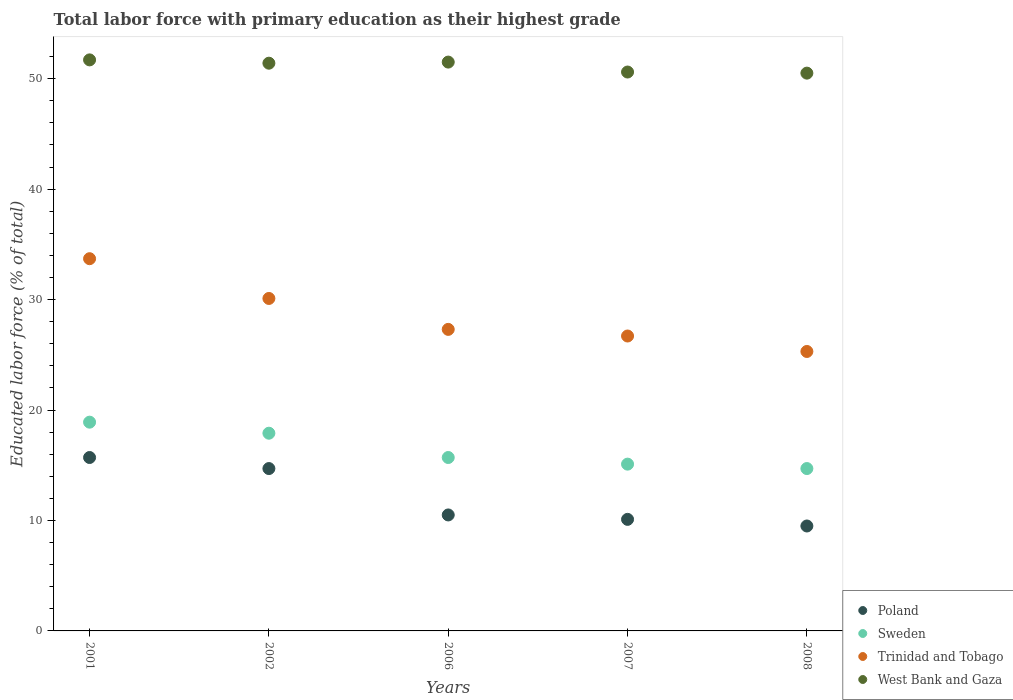How many different coloured dotlines are there?
Your answer should be very brief. 4. Is the number of dotlines equal to the number of legend labels?
Ensure brevity in your answer.  Yes. What is the percentage of total labor force with primary education in Poland in 2008?
Offer a very short reply. 9.5. Across all years, what is the maximum percentage of total labor force with primary education in Poland?
Your response must be concise. 15.7. Across all years, what is the minimum percentage of total labor force with primary education in Poland?
Make the answer very short. 9.5. In which year was the percentage of total labor force with primary education in West Bank and Gaza maximum?
Provide a short and direct response. 2001. What is the total percentage of total labor force with primary education in Sweden in the graph?
Give a very brief answer. 82.3. What is the difference between the percentage of total labor force with primary education in Trinidad and Tobago in 2001 and that in 2002?
Your response must be concise. 3.6. What is the difference between the percentage of total labor force with primary education in Trinidad and Tobago in 2006 and the percentage of total labor force with primary education in Sweden in 2002?
Your response must be concise. 9.4. What is the average percentage of total labor force with primary education in Sweden per year?
Give a very brief answer. 16.46. In the year 2002, what is the difference between the percentage of total labor force with primary education in Sweden and percentage of total labor force with primary education in West Bank and Gaza?
Make the answer very short. -33.5. In how many years, is the percentage of total labor force with primary education in Poland greater than 16 %?
Provide a succinct answer. 0. What is the ratio of the percentage of total labor force with primary education in Trinidad and Tobago in 2001 to that in 2008?
Make the answer very short. 1.33. Is the percentage of total labor force with primary education in Sweden in 2001 less than that in 2007?
Provide a short and direct response. No. Is the difference between the percentage of total labor force with primary education in Sweden in 2002 and 2006 greater than the difference between the percentage of total labor force with primary education in West Bank and Gaza in 2002 and 2006?
Offer a very short reply. Yes. What is the difference between the highest and the lowest percentage of total labor force with primary education in West Bank and Gaza?
Make the answer very short. 1.2. In how many years, is the percentage of total labor force with primary education in Poland greater than the average percentage of total labor force with primary education in Poland taken over all years?
Your answer should be compact. 2. Is it the case that in every year, the sum of the percentage of total labor force with primary education in Trinidad and Tobago and percentage of total labor force with primary education in West Bank and Gaza  is greater than the percentage of total labor force with primary education in Sweden?
Your answer should be compact. Yes. Is the percentage of total labor force with primary education in Sweden strictly greater than the percentage of total labor force with primary education in West Bank and Gaza over the years?
Keep it short and to the point. No. How many dotlines are there?
Your response must be concise. 4. What is the difference between two consecutive major ticks on the Y-axis?
Make the answer very short. 10. Does the graph contain grids?
Your answer should be very brief. No. Where does the legend appear in the graph?
Provide a succinct answer. Bottom right. How many legend labels are there?
Make the answer very short. 4. What is the title of the graph?
Your answer should be compact. Total labor force with primary education as their highest grade. Does "Kazakhstan" appear as one of the legend labels in the graph?
Provide a succinct answer. No. What is the label or title of the X-axis?
Ensure brevity in your answer.  Years. What is the label or title of the Y-axis?
Offer a very short reply. Educated labor force (% of total). What is the Educated labor force (% of total) of Poland in 2001?
Provide a short and direct response. 15.7. What is the Educated labor force (% of total) in Sweden in 2001?
Offer a terse response. 18.9. What is the Educated labor force (% of total) in Trinidad and Tobago in 2001?
Your answer should be compact. 33.7. What is the Educated labor force (% of total) of West Bank and Gaza in 2001?
Your response must be concise. 51.7. What is the Educated labor force (% of total) in Poland in 2002?
Provide a short and direct response. 14.7. What is the Educated labor force (% of total) of Sweden in 2002?
Provide a succinct answer. 17.9. What is the Educated labor force (% of total) of Trinidad and Tobago in 2002?
Provide a succinct answer. 30.1. What is the Educated labor force (% of total) of West Bank and Gaza in 2002?
Provide a succinct answer. 51.4. What is the Educated labor force (% of total) of Poland in 2006?
Your answer should be compact. 10.5. What is the Educated labor force (% of total) of Sweden in 2006?
Your answer should be compact. 15.7. What is the Educated labor force (% of total) of Trinidad and Tobago in 2006?
Provide a short and direct response. 27.3. What is the Educated labor force (% of total) of West Bank and Gaza in 2006?
Offer a terse response. 51.5. What is the Educated labor force (% of total) of Poland in 2007?
Provide a short and direct response. 10.1. What is the Educated labor force (% of total) in Sweden in 2007?
Offer a very short reply. 15.1. What is the Educated labor force (% of total) in Trinidad and Tobago in 2007?
Your response must be concise. 26.7. What is the Educated labor force (% of total) of West Bank and Gaza in 2007?
Your answer should be very brief. 50.6. What is the Educated labor force (% of total) of Sweden in 2008?
Ensure brevity in your answer.  14.7. What is the Educated labor force (% of total) of Trinidad and Tobago in 2008?
Make the answer very short. 25.3. What is the Educated labor force (% of total) in West Bank and Gaza in 2008?
Make the answer very short. 50.5. Across all years, what is the maximum Educated labor force (% of total) in Poland?
Provide a short and direct response. 15.7. Across all years, what is the maximum Educated labor force (% of total) of Sweden?
Provide a succinct answer. 18.9. Across all years, what is the maximum Educated labor force (% of total) of Trinidad and Tobago?
Offer a terse response. 33.7. Across all years, what is the maximum Educated labor force (% of total) in West Bank and Gaza?
Offer a very short reply. 51.7. Across all years, what is the minimum Educated labor force (% of total) of Poland?
Keep it short and to the point. 9.5. Across all years, what is the minimum Educated labor force (% of total) of Sweden?
Your answer should be very brief. 14.7. Across all years, what is the minimum Educated labor force (% of total) of Trinidad and Tobago?
Keep it short and to the point. 25.3. Across all years, what is the minimum Educated labor force (% of total) of West Bank and Gaza?
Your answer should be very brief. 50.5. What is the total Educated labor force (% of total) of Poland in the graph?
Offer a terse response. 60.5. What is the total Educated labor force (% of total) of Sweden in the graph?
Your answer should be very brief. 82.3. What is the total Educated labor force (% of total) of Trinidad and Tobago in the graph?
Provide a succinct answer. 143.1. What is the total Educated labor force (% of total) of West Bank and Gaza in the graph?
Ensure brevity in your answer.  255.7. What is the difference between the Educated labor force (% of total) of Sweden in 2001 and that in 2002?
Provide a succinct answer. 1. What is the difference between the Educated labor force (% of total) of Sweden in 2001 and that in 2006?
Offer a terse response. 3.2. What is the difference between the Educated labor force (% of total) of Trinidad and Tobago in 2001 and that in 2006?
Your answer should be compact. 6.4. What is the difference between the Educated labor force (% of total) of Poland in 2001 and that in 2007?
Give a very brief answer. 5.6. What is the difference between the Educated labor force (% of total) in West Bank and Gaza in 2001 and that in 2007?
Your response must be concise. 1.1. What is the difference between the Educated labor force (% of total) of Poland in 2001 and that in 2008?
Give a very brief answer. 6.2. What is the difference between the Educated labor force (% of total) in Trinidad and Tobago in 2001 and that in 2008?
Provide a succinct answer. 8.4. What is the difference between the Educated labor force (% of total) of West Bank and Gaza in 2002 and that in 2006?
Provide a short and direct response. -0.1. What is the difference between the Educated labor force (% of total) in Poland in 2002 and that in 2007?
Offer a very short reply. 4.6. What is the difference between the Educated labor force (% of total) of Trinidad and Tobago in 2002 and that in 2007?
Provide a short and direct response. 3.4. What is the difference between the Educated labor force (% of total) of Poland in 2006 and that in 2007?
Your response must be concise. 0.4. What is the difference between the Educated labor force (% of total) of Trinidad and Tobago in 2006 and that in 2007?
Make the answer very short. 0.6. What is the difference between the Educated labor force (% of total) of Sweden in 2006 and that in 2008?
Offer a terse response. 1. What is the difference between the Educated labor force (% of total) in Poland in 2007 and that in 2008?
Make the answer very short. 0.6. What is the difference between the Educated labor force (% of total) in West Bank and Gaza in 2007 and that in 2008?
Make the answer very short. 0.1. What is the difference between the Educated labor force (% of total) of Poland in 2001 and the Educated labor force (% of total) of Sweden in 2002?
Your answer should be compact. -2.2. What is the difference between the Educated labor force (% of total) of Poland in 2001 and the Educated labor force (% of total) of Trinidad and Tobago in 2002?
Provide a short and direct response. -14.4. What is the difference between the Educated labor force (% of total) in Poland in 2001 and the Educated labor force (% of total) in West Bank and Gaza in 2002?
Your answer should be very brief. -35.7. What is the difference between the Educated labor force (% of total) in Sweden in 2001 and the Educated labor force (% of total) in West Bank and Gaza in 2002?
Keep it short and to the point. -32.5. What is the difference between the Educated labor force (% of total) of Trinidad and Tobago in 2001 and the Educated labor force (% of total) of West Bank and Gaza in 2002?
Ensure brevity in your answer.  -17.7. What is the difference between the Educated labor force (% of total) of Poland in 2001 and the Educated labor force (% of total) of West Bank and Gaza in 2006?
Keep it short and to the point. -35.8. What is the difference between the Educated labor force (% of total) of Sweden in 2001 and the Educated labor force (% of total) of Trinidad and Tobago in 2006?
Your answer should be compact. -8.4. What is the difference between the Educated labor force (% of total) in Sweden in 2001 and the Educated labor force (% of total) in West Bank and Gaza in 2006?
Your response must be concise. -32.6. What is the difference between the Educated labor force (% of total) of Trinidad and Tobago in 2001 and the Educated labor force (% of total) of West Bank and Gaza in 2006?
Keep it short and to the point. -17.8. What is the difference between the Educated labor force (% of total) of Poland in 2001 and the Educated labor force (% of total) of Sweden in 2007?
Offer a very short reply. 0.6. What is the difference between the Educated labor force (% of total) in Poland in 2001 and the Educated labor force (% of total) in Trinidad and Tobago in 2007?
Ensure brevity in your answer.  -11. What is the difference between the Educated labor force (% of total) in Poland in 2001 and the Educated labor force (% of total) in West Bank and Gaza in 2007?
Make the answer very short. -34.9. What is the difference between the Educated labor force (% of total) in Sweden in 2001 and the Educated labor force (% of total) in Trinidad and Tobago in 2007?
Give a very brief answer. -7.8. What is the difference between the Educated labor force (% of total) of Sweden in 2001 and the Educated labor force (% of total) of West Bank and Gaza in 2007?
Offer a very short reply. -31.7. What is the difference between the Educated labor force (% of total) of Trinidad and Tobago in 2001 and the Educated labor force (% of total) of West Bank and Gaza in 2007?
Your answer should be very brief. -16.9. What is the difference between the Educated labor force (% of total) of Poland in 2001 and the Educated labor force (% of total) of Sweden in 2008?
Offer a very short reply. 1. What is the difference between the Educated labor force (% of total) in Poland in 2001 and the Educated labor force (% of total) in West Bank and Gaza in 2008?
Your response must be concise. -34.8. What is the difference between the Educated labor force (% of total) of Sweden in 2001 and the Educated labor force (% of total) of Trinidad and Tobago in 2008?
Provide a succinct answer. -6.4. What is the difference between the Educated labor force (% of total) of Sweden in 2001 and the Educated labor force (% of total) of West Bank and Gaza in 2008?
Keep it short and to the point. -31.6. What is the difference between the Educated labor force (% of total) in Trinidad and Tobago in 2001 and the Educated labor force (% of total) in West Bank and Gaza in 2008?
Ensure brevity in your answer.  -16.8. What is the difference between the Educated labor force (% of total) of Poland in 2002 and the Educated labor force (% of total) of West Bank and Gaza in 2006?
Provide a succinct answer. -36.8. What is the difference between the Educated labor force (% of total) of Sweden in 2002 and the Educated labor force (% of total) of West Bank and Gaza in 2006?
Give a very brief answer. -33.6. What is the difference between the Educated labor force (% of total) of Trinidad and Tobago in 2002 and the Educated labor force (% of total) of West Bank and Gaza in 2006?
Make the answer very short. -21.4. What is the difference between the Educated labor force (% of total) in Poland in 2002 and the Educated labor force (% of total) in Sweden in 2007?
Keep it short and to the point. -0.4. What is the difference between the Educated labor force (% of total) of Poland in 2002 and the Educated labor force (% of total) of Trinidad and Tobago in 2007?
Ensure brevity in your answer.  -12. What is the difference between the Educated labor force (% of total) of Poland in 2002 and the Educated labor force (% of total) of West Bank and Gaza in 2007?
Your response must be concise. -35.9. What is the difference between the Educated labor force (% of total) in Sweden in 2002 and the Educated labor force (% of total) in West Bank and Gaza in 2007?
Give a very brief answer. -32.7. What is the difference between the Educated labor force (% of total) of Trinidad and Tobago in 2002 and the Educated labor force (% of total) of West Bank and Gaza in 2007?
Provide a short and direct response. -20.5. What is the difference between the Educated labor force (% of total) in Poland in 2002 and the Educated labor force (% of total) in Sweden in 2008?
Your response must be concise. 0. What is the difference between the Educated labor force (% of total) of Poland in 2002 and the Educated labor force (% of total) of Trinidad and Tobago in 2008?
Your answer should be very brief. -10.6. What is the difference between the Educated labor force (% of total) in Poland in 2002 and the Educated labor force (% of total) in West Bank and Gaza in 2008?
Offer a very short reply. -35.8. What is the difference between the Educated labor force (% of total) in Sweden in 2002 and the Educated labor force (% of total) in West Bank and Gaza in 2008?
Give a very brief answer. -32.6. What is the difference between the Educated labor force (% of total) of Trinidad and Tobago in 2002 and the Educated labor force (% of total) of West Bank and Gaza in 2008?
Offer a very short reply. -20.4. What is the difference between the Educated labor force (% of total) of Poland in 2006 and the Educated labor force (% of total) of Sweden in 2007?
Keep it short and to the point. -4.6. What is the difference between the Educated labor force (% of total) of Poland in 2006 and the Educated labor force (% of total) of Trinidad and Tobago in 2007?
Your response must be concise. -16.2. What is the difference between the Educated labor force (% of total) in Poland in 2006 and the Educated labor force (% of total) in West Bank and Gaza in 2007?
Offer a terse response. -40.1. What is the difference between the Educated labor force (% of total) in Sweden in 2006 and the Educated labor force (% of total) in Trinidad and Tobago in 2007?
Offer a very short reply. -11. What is the difference between the Educated labor force (% of total) of Sweden in 2006 and the Educated labor force (% of total) of West Bank and Gaza in 2007?
Keep it short and to the point. -34.9. What is the difference between the Educated labor force (% of total) of Trinidad and Tobago in 2006 and the Educated labor force (% of total) of West Bank and Gaza in 2007?
Ensure brevity in your answer.  -23.3. What is the difference between the Educated labor force (% of total) of Poland in 2006 and the Educated labor force (% of total) of Trinidad and Tobago in 2008?
Ensure brevity in your answer.  -14.8. What is the difference between the Educated labor force (% of total) of Poland in 2006 and the Educated labor force (% of total) of West Bank and Gaza in 2008?
Provide a succinct answer. -40. What is the difference between the Educated labor force (% of total) in Sweden in 2006 and the Educated labor force (% of total) in West Bank and Gaza in 2008?
Provide a succinct answer. -34.8. What is the difference between the Educated labor force (% of total) in Trinidad and Tobago in 2006 and the Educated labor force (% of total) in West Bank and Gaza in 2008?
Make the answer very short. -23.2. What is the difference between the Educated labor force (% of total) of Poland in 2007 and the Educated labor force (% of total) of Trinidad and Tobago in 2008?
Provide a short and direct response. -15.2. What is the difference between the Educated labor force (% of total) of Poland in 2007 and the Educated labor force (% of total) of West Bank and Gaza in 2008?
Ensure brevity in your answer.  -40.4. What is the difference between the Educated labor force (% of total) of Sweden in 2007 and the Educated labor force (% of total) of Trinidad and Tobago in 2008?
Your answer should be very brief. -10.2. What is the difference between the Educated labor force (% of total) in Sweden in 2007 and the Educated labor force (% of total) in West Bank and Gaza in 2008?
Your answer should be very brief. -35.4. What is the difference between the Educated labor force (% of total) of Trinidad and Tobago in 2007 and the Educated labor force (% of total) of West Bank and Gaza in 2008?
Ensure brevity in your answer.  -23.8. What is the average Educated labor force (% of total) in Poland per year?
Provide a short and direct response. 12.1. What is the average Educated labor force (% of total) in Sweden per year?
Make the answer very short. 16.46. What is the average Educated labor force (% of total) in Trinidad and Tobago per year?
Make the answer very short. 28.62. What is the average Educated labor force (% of total) of West Bank and Gaza per year?
Your response must be concise. 51.14. In the year 2001, what is the difference between the Educated labor force (% of total) in Poland and Educated labor force (% of total) in West Bank and Gaza?
Offer a terse response. -36. In the year 2001, what is the difference between the Educated labor force (% of total) of Sweden and Educated labor force (% of total) of Trinidad and Tobago?
Provide a short and direct response. -14.8. In the year 2001, what is the difference between the Educated labor force (% of total) of Sweden and Educated labor force (% of total) of West Bank and Gaza?
Your response must be concise. -32.8. In the year 2001, what is the difference between the Educated labor force (% of total) in Trinidad and Tobago and Educated labor force (% of total) in West Bank and Gaza?
Offer a very short reply. -18. In the year 2002, what is the difference between the Educated labor force (% of total) in Poland and Educated labor force (% of total) in Sweden?
Make the answer very short. -3.2. In the year 2002, what is the difference between the Educated labor force (% of total) in Poland and Educated labor force (% of total) in Trinidad and Tobago?
Your answer should be compact. -15.4. In the year 2002, what is the difference between the Educated labor force (% of total) of Poland and Educated labor force (% of total) of West Bank and Gaza?
Offer a very short reply. -36.7. In the year 2002, what is the difference between the Educated labor force (% of total) of Sweden and Educated labor force (% of total) of Trinidad and Tobago?
Keep it short and to the point. -12.2. In the year 2002, what is the difference between the Educated labor force (% of total) in Sweden and Educated labor force (% of total) in West Bank and Gaza?
Your answer should be compact. -33.5. In the year 2002, what is the difference between the Educated labor force (% of total) of Trinidad and Tobago and Educated labor force (% of total) of West Bank and Gaza?
Keep it short and to the point. -21.3. In the year 2006, what is the difference between the Educated labor force (% of total) in Poland and Educated labor force (% of total) in Sweden?
Keep it short and to the point. -5.2. In the year 2006, what is the difference between the Educated labor force (% of total) in Poland and Educated labor force (% of total) in Trinidad and Tobago?
Make the answer very short. -16.8. In the year 2006, what is the difference between the Educated labor force (% of total) of Poland and Educated labor force (% of total) of West Bank and Gaza?
Provide a succinct answer. -41. In the year 2006, what is the difference between the Educated labor force (% of total) of Sweden and Educated labor force (% of total) of Trinidad and Tobago?
Keep it short and to the point. -11.6. In the year 2006, what is the difference between the Educated labor force (% of total) of Sweden and Educated labor force (% of total) of West Bank and Gaza?
Give a very brief answer. -35.8. In the year 2006, what is the difference between the Educated labor force (% of total) of Trinidad and Tobago and Educated labor force (% of total) of West Bank and Gaza?
Provide a succinct answer. -24.2. In the year 2007, what is the difference between the Educated labor force (% of total) of Poland and Educated labor force (% of total) of Trinidad and Tobago?
Give a very brief answer. -16.6. In the year 2007, what is the difference between the Educated labor force (% of total) in Poland and Educated labor force (% of total) in West Bank and Gaza?
Provide a succinct answer. -40.5. In the year 2007, what is the difference between the Educated labor force (% of total) of Sweden and Educated labor force (% of total) of West Bank and Gaza?
Keep it short and to the point. -35.5. In the year 2007, what is the difference between the Educated labor force (% of total) in Trinidad and Tobago and Educated labor force (% of total) in West Bank and Gaza?
Your answer should be compact. -23.9. In the year 2008, what is the difference between the Educated labor force (% of total) in Poland and Educated labor force (% of total) in Trinidad and Tobago?
Your answer should be compact. -15.8. In the year 2008, what is the difference between the Educated labor force (% of total) in Poland and Educated labor force (% of total) in West Bank and Gaza?
Your answer should be compact. -41. In the year 2008, what is the difference between the Educated labor force (% of total) in Sweden and Educated labor force (% of total) in West Bank and Gaza?
Make the answer very short. -35.8. In the year 2008, what is the difference between the Educated labor force (% of total) in Trinidad and Tobago and Educated labor force (% of total) in West Bank and Gaza?
Provide a succinct answer. -25.2. What is the ratio of the Educated labor force (% of total) in Poland in 2001 to that in 2002?
Your response must be concise. 1.07. What is the ratio of the Educated labor force (% of total) of Sweden in 2001 to that in 2002?
Keep it short and to the point. 1.06. What is the ratio of the Educated labor force (% of total) of Trinidad and Tobago in 2001 to that in 2002?
Your answer should be very brief. 1.12. What is the ratio of the Educated labor force (% of total) in Poland in 2001 to that in 2006?
Make the answer very short. 1.5. What is the ratio of the Educated labor force (% of total) in Sweden in 2001 to that in 2006?
Your response must be concise. 1.2. What is the ratio of the Educated labor force (% of total) of Trinidad and Tobago in 2001 to that in 2006?
Make the answer very short. 1.23. What is the ratio of the Educated labor force (% of total) of West Bank and Gaza in 2001 to that in 2006?
Your answer should be compact. 1. What is the ratio of the Educated labor force (% of total) of Poland in 2001 to that in 2007?
Give a very brief answer. 1.55. What is the ratio of the Educated labor force (% of total) in Sweden in 2001 to that in 2007?
Your answer should be compact. 1.25. What is the ratio of the Educated labor force (% of total) in Trinidad and Tobago in 2001 to that in 2007?
Keep it short and to the point. 1.26. What is the ratio of the Educated labor force (% of total) of West Bank and Gaza in 2001 to that in 2007?
Provide a short and direct response. 1.02. What is the ratio of the Educated labor force (% of total) in Poland in 2001 to that in 2008?
Your response must be concise. 1.65. What is the ratio of the Educated labor force (% of total) in Sweden in 2001 to that in 2008?
Offer a very short reply. 1.29. What is the ratio of the Educated labor force (% of total) in Trinidad and Tobago in 2001 to that in 2008?
Your response must be concise. 1.33. What is the ratio of the Educated labor force (% of total) of West Bank and Gaza in 2001 to that in 2008?
Keep it short and to the point. 1.02. What is the ratio of the Educated labor force (% of total) in Poland in 2002 to that in 2006?
Provide a succinct answer. 1.4. What is the ratio of the Educated labor force (% of total) in Sweden in 2002 to that in 2006?
Your response must be concise. 1.14. What is the ratio of the Educated labor force (% of total) in Trinidad and Tobago in 2002 to that in 2006?
Offer a very short reply. 1.1. What is the ratio of the Educated labor force (% of total) of Poland in 2002 to that in 2007?
Your response must be concise. 1.46. What is the ratio of the Educated labor force (% of total) in Sweden in 2002 to that in 2007?
Provide a succinct answer. 1.19. What is the ratio of the Educated labor force (% of total) in Trinidad and Tobago in 2002 to that in 2007?
Your answer should be very brief. 1.13. What is the ratio of the Educated labor force (% of total) in West Bank and Gaza in 2002 to that in 2007?
Offer a very short reply. 1.02. What is the ratio of the Educated labor force (% of total) in Poland in 2002 to that in 2008?
Your answer should be very brief. 1.55. What is the ratio of the Educated labor force (% of total) in Sweden in 2002 to that in 2008?
Keep it short and to the point. 1.22. What is the ratio of the Educated labor force (% of total) of Trinidad and Tobago in 2002 to that in 2008?
Ensure brevity in your answer.  1.19. What is the ratio of the Educated labor force (% of total) of West Bank and Gaza in 2002 to that in 2008?
Offer a terse response. 1.02. What is the ratio of the Educated labor force (% of total) in Poland in 2006 to that in 2007?
Your response must be concise. 1.04. What is the ratio of the Educated labor force (% of total) in Sweden in 2006 to that in 2007?
Your answer should be compact. 1.04. What is the ratio of the Educated labor force (% of total) in Trinidad and Tobago in 2006 to that in 2007?
Ensure brevity in your answer.  1.02. What is the ratio of the Educated labor force (% of total) in West Bank and Gaza in 2006 to that in 2007?
Give a very brief answer. 1.02. What is the ratio of the Educated labor force (% of total) in Poland in 2006 to that in 2008?
Keep it short and to the point. 1.11. What is the ratio of the Educated labor force (% of total) of Sweden in 2006 to that in 2008?
Offer a very short reply. 1.07. What is the ratio of the Educated labor force (% of total) in Trinidad and Tobago in 2006 to that in 2008?
Provide a succinct answer. 1.08. What is the ratio of the Educated labor force (% of total) in West Bank and Gaza in 2006 to that in 2008?
Make the answer very short. 1.02. What is the ratio of the Educated labor force (% of total) of Poland in 2007 to that in 2008?
Offer a very short reply. 1.06. What is the ratio of the Educated labor force (% of total) of Sweden in 2007 to that in 2008?
Provide a succinct answer. 1.03. What is the ratio of the Educated labor force (% of total) in Trinidad and Tobago in 2007 to that in 2008?
Your answer should be very brief. 1.06. What is the ratio of the Educated labor force (% of total) of West Bank and Gaza in 2007 to that in 2008?
Provide a succinct answer. 1. What is the difference between the highest and the second highest Educated labor force (% of total) in Sweden?
Your answer should be compact. 1. What is the difference between the highest and the lowest Educated labor force (% of total) in Trinidad and Tobago?
Your response must be concise. 8.4. What is the difference between the highest and the lowest Educated labor force (% of total) of West Bank and Gaza?
Offer a terse response. 1.2. 